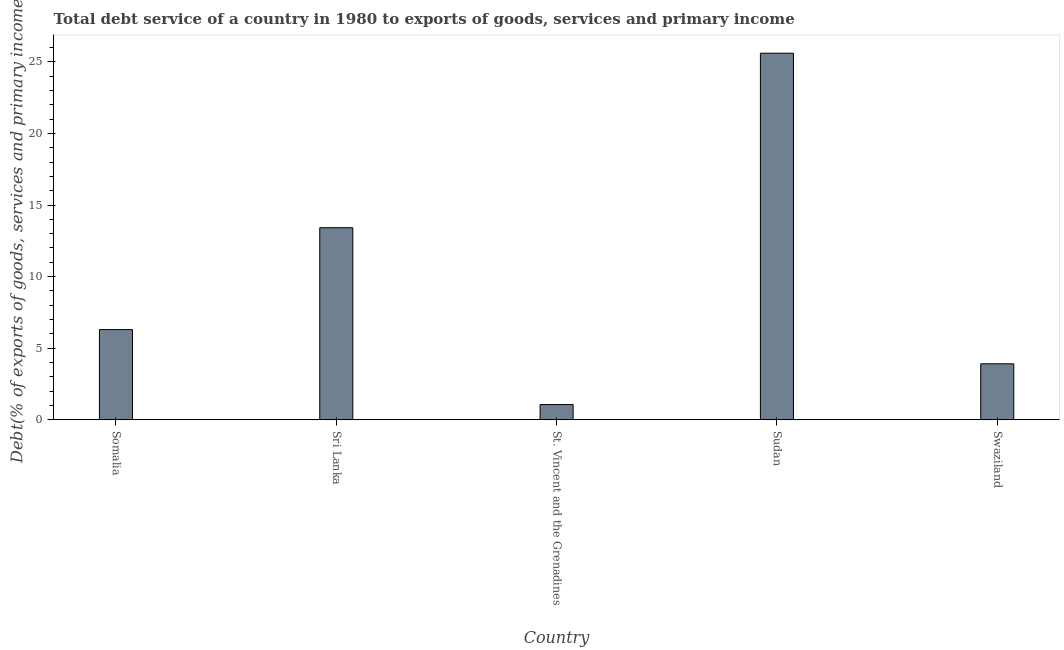Does the graph contain any zero values?
Make the answer very short. No. Does the graph contain grids?
Keep it short and to the point. No. What is the title of the graph?
Make the answer very short. Total debt service of a country in 1980 to exports of goods, services and primary income. What is the label or title of the X-axis?
Your answer should be very brief. Country. What is the label or title of the Y-axis?
Make the answer very short. Debt(% of exports of goods, services and primary income). What is the total debt service in Somalia?
Your response must be concise. 6.3. Across all countries, what is the maximum total debt service?
Make the answer very short. 25.6. Across all countries, what is the minimum total debt service?
Your response must be concise. 1.07. In which country was the total debt service maximum?
Offer a terse response. Sudan. In which country was the total debt service minimum?
Ensure brevity in your answer.  St. Vincent and the Grenadines. What is the sum of the total debt service?
Provide a short and direct response. 50.3. What is the difference between the total debt service in Somalia and St. Vincent and the Grenadines?
Your answer should be compact. 5.24. What is the average total debt service per country?
Make the answer very short. 10.06. What is the median total debt service?
Offer a very short reply. 6.3. What is the ratio of the total debt service in St. Vincent and the Grenadines to that in Swaziland?
Give a very brief answer. 0.27. Is the total debt service in St. Vincent and the Grenadines less than that in Sudan?
Your answer should be very brief. Yes. What is the difference between the highest and the second highest total debt service?
Offer a very short reply. 12.19. What is the difference between the highest and the lowest total debt service?
Keep it short and to the point. 24.54. In how many countries, is the total debt service greater than the average total debt service taken over all countries?
Make the answer very short. 2. How many bars are there?
Offer a very short reply. 5. Are all the bars in the graph horizontal?
Your answer should be compact. No. How many countries are there in the graph?
Ensure brevity in your answer.  5. What is the difference between two consecutive major ticks on the Y-axis?
Your response must be concise. 5. Are the values on the major ticks of Y-axis written in scientific E-notation?
Your answer should be compact. No. What is the Debt(% of exports of goods, services and primary income) of Somalia?
Keep it short and to the point. 6.3. What is the Debt(% of exports of goods, services and primary income) of Sri Lanka?
Make the answer very short. 13.42. What is the Debt(% of exports of goods, services and primary income) of St. Vincent and the Grenadines?
Your answer should be very brief. 1.07. What is the Debt(% of exports of goods, services and primary income) in Sudan?
Provide a succinct answer. 25.6. What is the Debt(% of exports of goods, services and primary income) in Swaziland?
Your response must be concise. 3.91. What is the difference between the Debt(% of exports of goods, services and primary income) in Somalia and Sri Lanka?
Provide a short and direct response. -7.12. What is the difference between the Debt(% of exports of goods, services and primary income) in Somalia and St. Vincent and the Grenadines?
Your answer should be compact. 5.23. What is the difference between the Debt(% of exports of goods, services and primary income) in Somalia and Sudan?
Ensure brevity in your answer.  -19.3. What is the difference between the Debt(% of exports of goods, services and primary income) in Somalia and Swaziland?
Give a very brief answer. 2.39. What is the difference between the Debt(% of exports of goods, services and primary income) in Sri Lanka and St. Vincent and the Grenadines?
Ensure brevity in your answer.  12.35. What is the difference between the Debt(% of exports of goods, services and primary income) in Sri Lanka and Sudan?
Make the answer very short. -12.19. What is the difference between the Debt(% of exports of goods, services and primary income) in Sri Lanka and Swaziland?
Your response must be concise. 9.51. What is the difference between the Debt(% of exports of goods, services and primary income) in St. Vincent and the Grenadines and Sudan?
Offer a very short reply. -24.54. What is the difference between the Debt(% of exports of goods, services and primary income) in St. Vincent and the Grenadines and Swaziland?
Offer a very short reply. -2.84. What is the difference between the Debt(% of exports of goods, services and primary income) in Sudan and Swaziland?
Offer a very short reply. 21.69. What is the ratio of the Debt(% of exports of goods, services and primary income) in Somalia to that in Sri Lanka?
Make the answer very short. 0.47. What is the ratio of the Debt(% of exports of goods, services and primary income) in Somalia to that in St. Vincent and the Grenadines?
Make the answer very short. 5.91. What is the ratio of the Debt(% of exports of goods, services and primary income) in Somalia to that in Sudan?
Provide a succinct answer. 0.25. What is the ratio of the Debt(% of exports of goods, services and primary income) in Somalia to that in Swaziland?
Offer a terse response. 1.61. What is the ratio of the Debt(% of exports of goods, services and primary income) in Sri Lanka to that in St. Vincent and the Grenadines?
Keep it short and to the point. 12.59. What is the ratio of the Debt(% of exports of goods, services and primary income) in Sri Lanka to that in Sudan?
Offer a very short reply. 0.52. What is the ratio of the Debt(% of exports of goods, services and primary income) in Sri Lanka to that in Swaziland?
Your answer should be very brief. 3.43. What is the ratio of the Debt(% of exports of goods, services and primary income) in St. Vincent and the Grenadines to that in Sudan?
Provide a short and direct response. 0.04. What is the ratio of the Debt(% of exports of goods, services and primary income) in St. Vincent and the Grenadines to that in Swaziland?
Offer a very short reply. 0.27. What is the ratio of the Debt(% of exports of goods, services and primary income) in Sudan to that in Swaziland?
Provide a short and direct response. 6.55. 